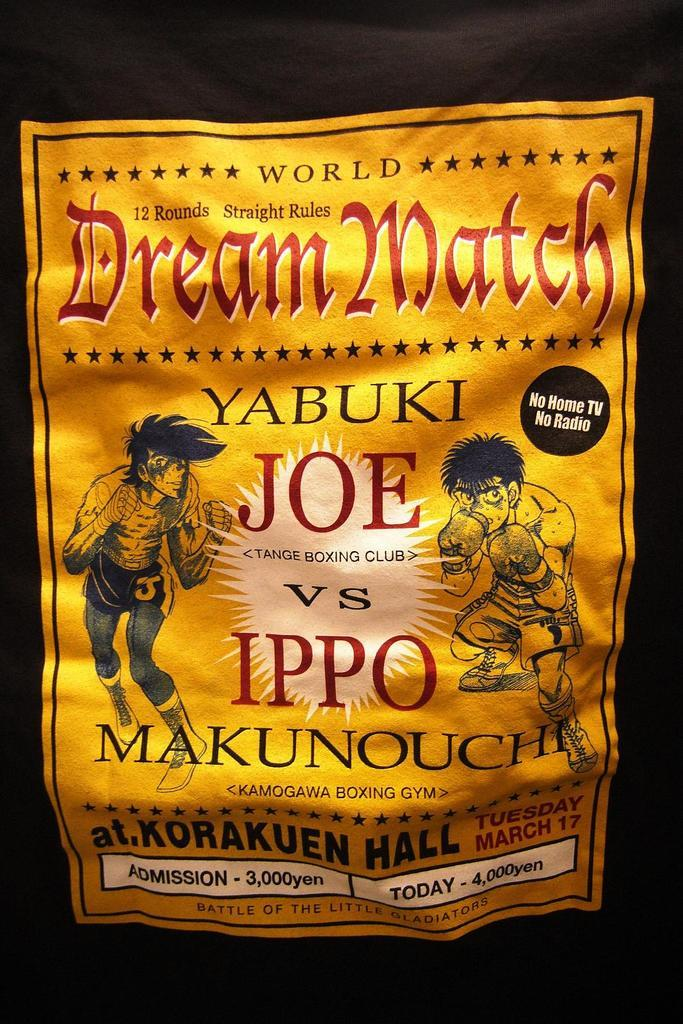<image>
Give a short and clear explanation of the subsequent image. A poster advertises a boxing Dream Match governed by Straight Rules and lasting 12 Rounds. 